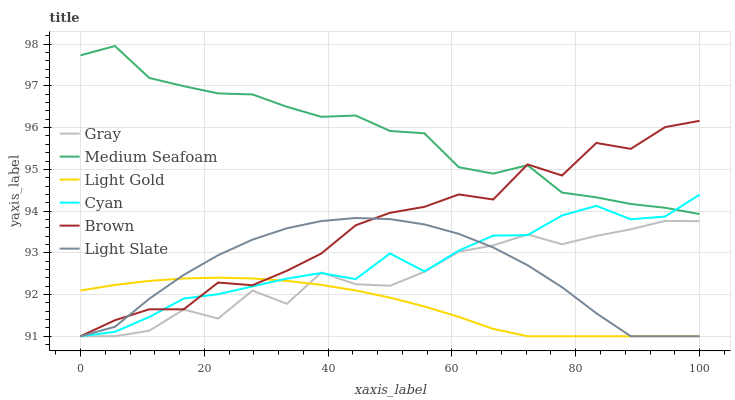Does Light Gold have the minimum area under the curve?
Answer yes or no. Yes. Does Medium Seafoam have the maximum area under the curve?
Answer yes or no. Yes. Does Brown have the minimum area under the curve?
Answer yes or no. No. Does Brown have the maximum area under the curve?
Answer yes or no. No. Is Light Gold the smoothest?
Answer yes or no. Yes. Is Brown the roughest?
Answer yes or no. Yes. Is Light Slate the smoothest?
Answer yes or no. No. Is Light Slate the roughest?
Answer yes or no. No. Does Gray have the lowest value?
Answer yes or no. Yes. Does Medium Seafoam have the lowest value?
Answer yes or no. No. Does Medium Seafoam have the highest value?
Answer yes or no. Yes. Does Brown have the highest value?
Answer yes or no. No. Is Gray less than Medium Seafoam?
Answer yes or no. Yes. Is Medium Seafoam greater than Gray?
Answer yes or no. Yes. Does Gray intersect Light Slate?
Answer yes or no. Yes. Is Gray less than Light Slate?
Answer yes or no. No. Is Gray greater than Light Slate?
Answer yes or no. No. Does Gray intersect Medium Seafoam?
Answer yes or no. No. 